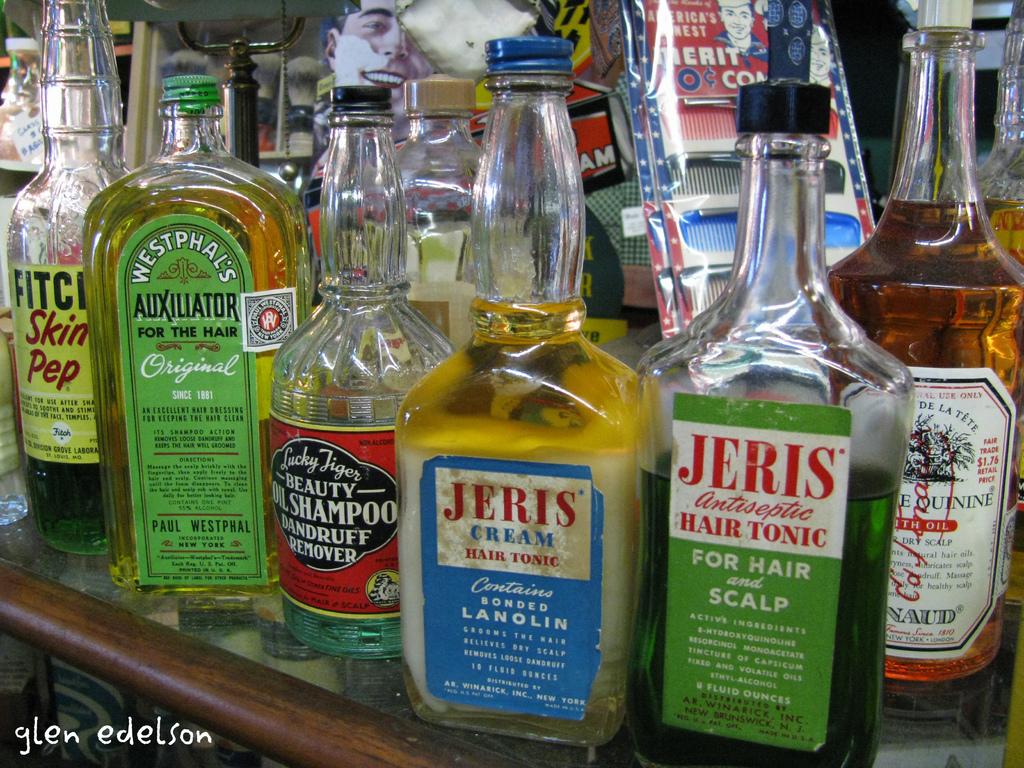Who took the picture?
Make the answer very short. Glen edelson. 